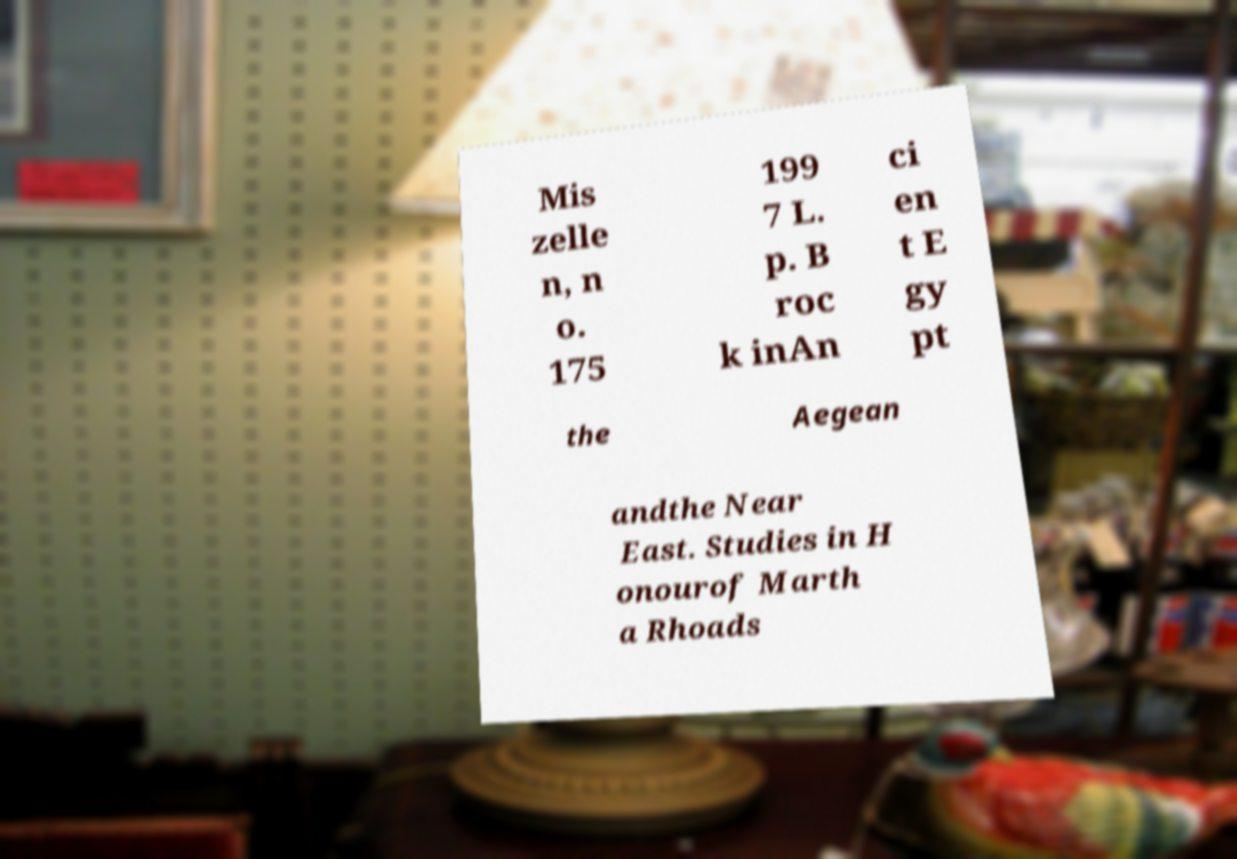For documentation purposes, I need the text within this image transcribed. Could you provide that? Mis zelle n, n o. 175 199 7 L. p. B roc k inAn ci en t E gy pt the Aegean andthe Near East. Studies in H onourof Marth a Rhoads 